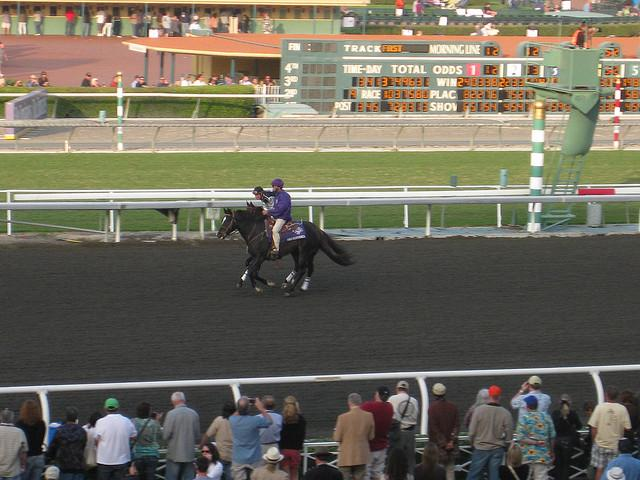What type of event is being held? horse race 